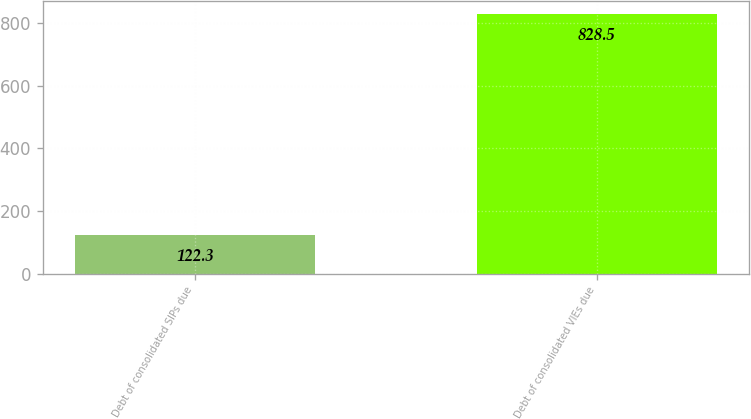Convert chart. <chart><loc_0><loc_0><loc_500><loc_500><bar_chart><fcel>Debt of consolidated SIPs due<fcel>Debt of consolidated VIEs due<nl><fcel>122.3<fcel>828.5<nl></chart> 